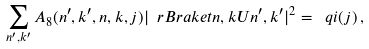Convert formula to latex. <formula><loc_0><loc_0><loc_500><loc_500>\sum _ { n ^ { \prime } , k ^ { \prime } } A _ { 8 } ( n ^ { \prime } , k ^ { \prime } , n , k , j ) | \ r B r a k e t { n , k } { U } { n ^ { \prime } , k ^ { \prime } } | ^ { 2 } = \ q i ( j ) \, ,</formula> 